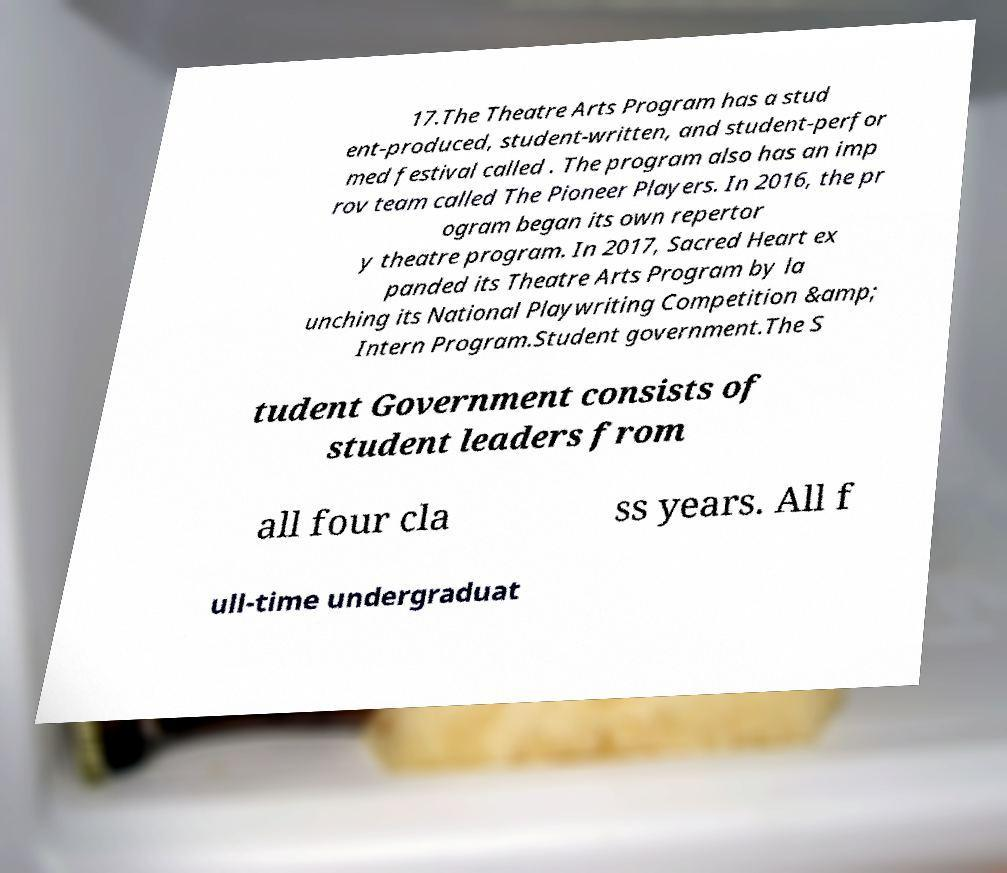What messages or text are displayed in this image? I need them in a readable, typed format. 17.The Theatre Arts Program has a stud ent-produced, student-written, and student-perfor med festival called . The program also has an imp rov team called The Pioneer Players. In 2016, the pr ogram began its own repertor y theatre program. In 2017, Sacred Heart ex panded its Theatre Arts Program by la unching its National Playwriting Competition &amp; Intern Program.Student government.The S tudent Government consists of student leaders from all four cla ss years. All f ull-time undergraduat 